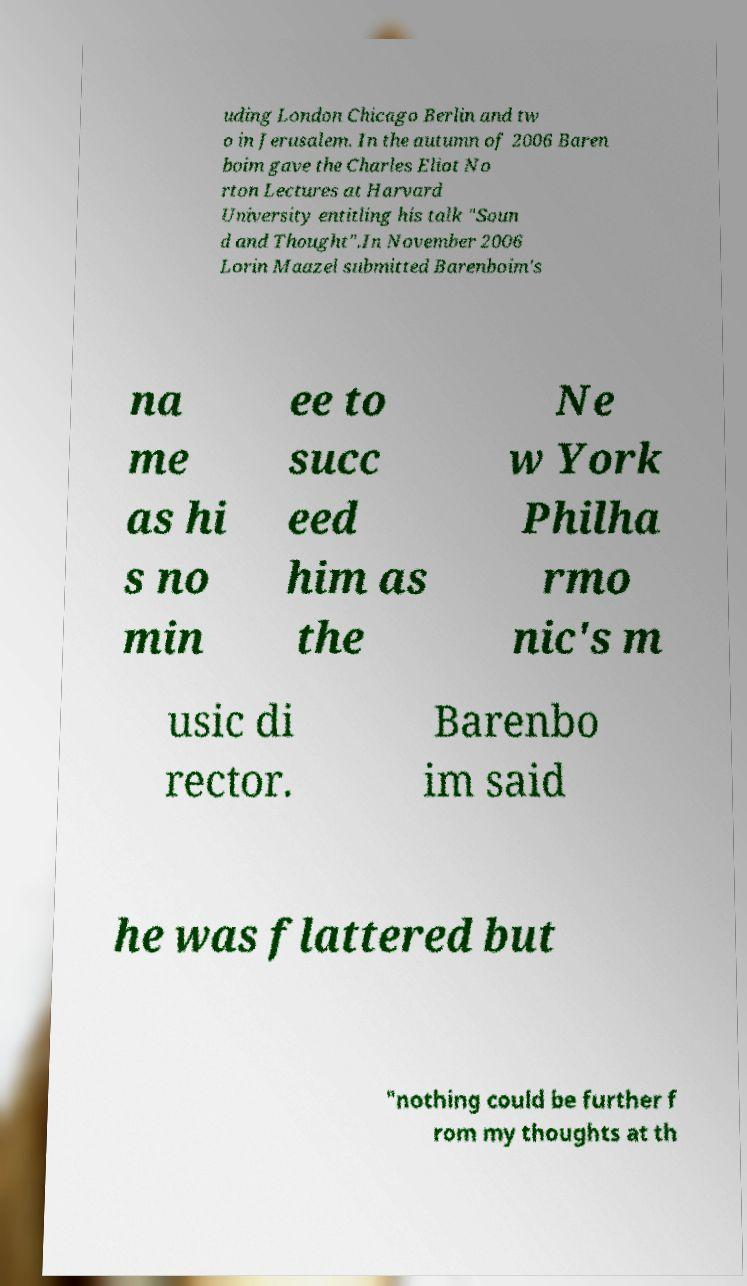Could you extract and type out the text from this image? uding London Chicago Berlin and tw o in Jerusalem. In the autumn of 2006 Baren boim gave the Charles Eliot No rton Lectures at Harvard University entitling his talk "Soun d and Thought".In November 2006 Lorin Maazel submitted Barenboim's na me as hi s no min ee to succ eed him as the Ne w York Philha rmo nic's m usic di rector. Barenbo im said he was flattered but "nothing could be further f rom my thoughts at th 